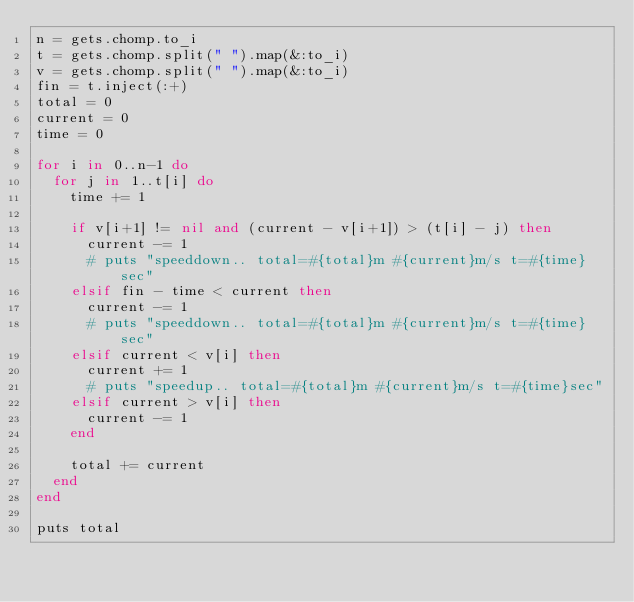Convert code to text. <code><loc_0><loc_0><loc_500><loc_500><_Ruby_>n = gets.chomp.to_i
t = gets.chomp.split(" ").map(&:to_i)
v = gets.chomp.split(" ").map(&:to_i)
fin = t.inject(:+)
total = 0
current = 0
time = 0

for i in 0..n-1 do
  for j in 1..t[i] do
    time += 1

    if v[i+1] != nil and (current - v[i+1]) > (t[i] - j) then
      current -= 1 
      # puts "speeddown.. total=#{total}m #{current}m/s t=#{time}sec"
    elsif fin - time < current then
      current -= 1 
      # puts "speeddown.. total=#{total}m #{current}m/s t=#{time}sec"
    elsif current < v[i] then
      current += 1 
      # puts "speedup.. total=#{total}m #{current}m/s t=#{time}sec"
    elsif current > v[i] then
      current -= 1 
    end

    total += current
  end
end

puts total</code> 